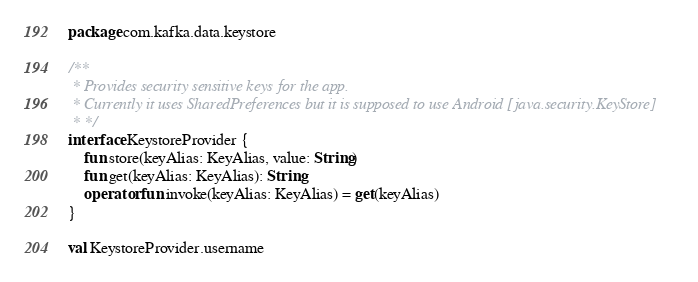<code> <loc_0><loc_0><loc_500><loc_500><_Kotlin_>package com.kafka.data.keystore

/**
 * Provides security sensitive keys for the app.
 * Currently it uses SharedPreferences but it is supposed to use Android [java.security.KeyStore]
 * */
interface KeystoreProvider {
    fun store(keyAlias: KeyAlias, value: String)
    fun get(keyAlias: KeyAlias): String
    operator fun invoke(keyAlias: KeyAlias) = get(keyAlias)
}

val KeystoreProvider.username</code> 